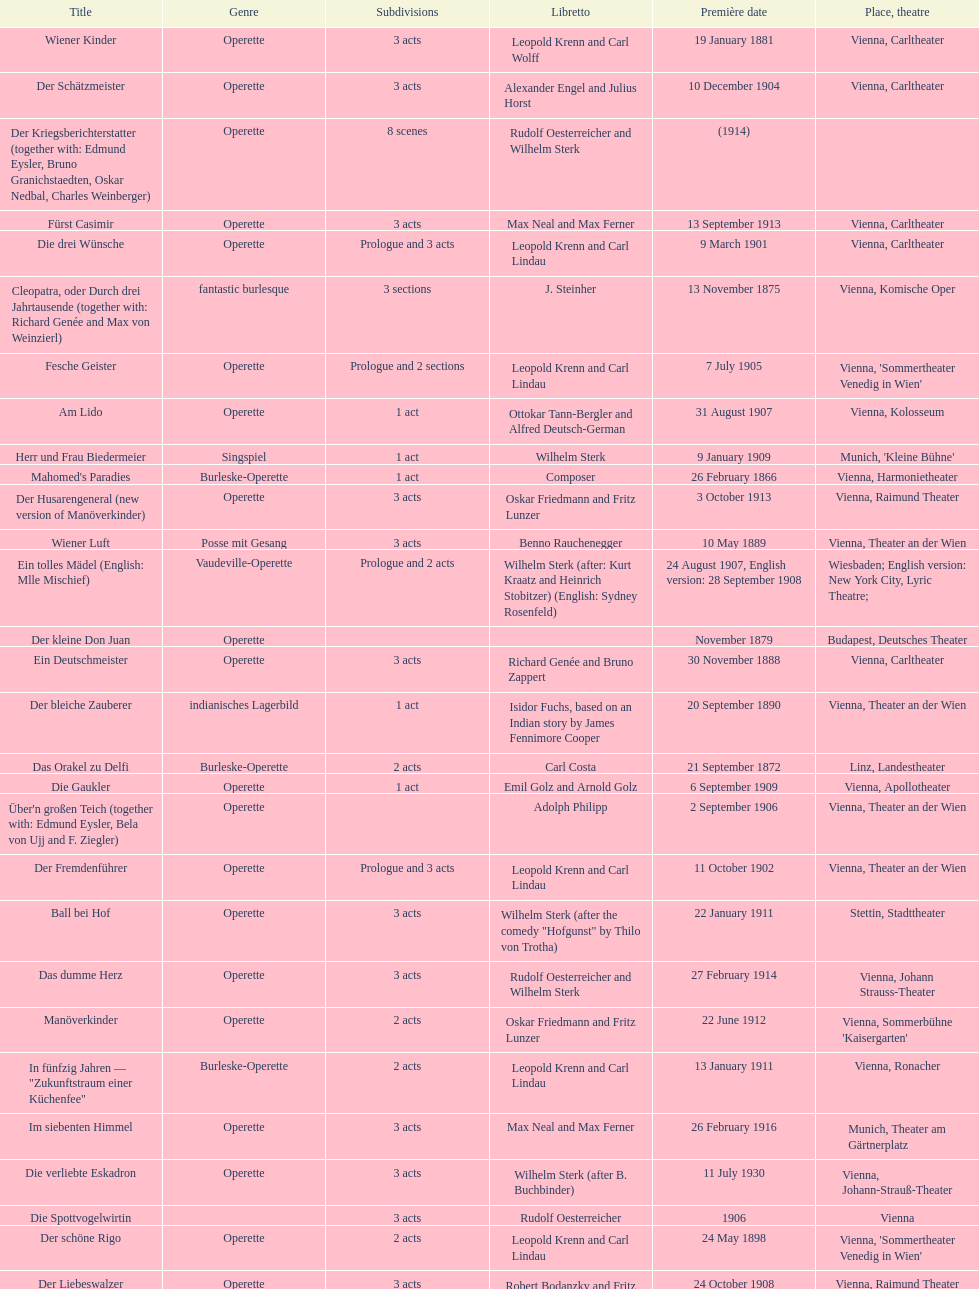How many of his operettas were 3 acts? 13. 